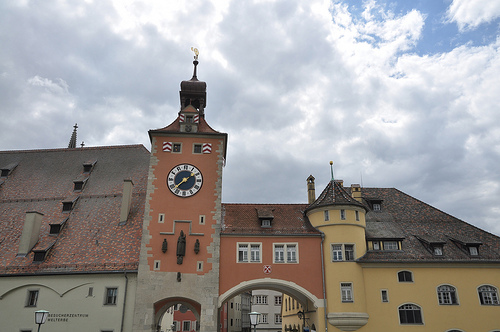Describe the architectural style of the buildings. The buildings in the image showcase a blend of traditional European architecture, featuring elements such as steeply pitched roofs, arched doorways, and windows with wooden shutters. What time period do these buildings appear to be from? The architectural features suggest that these buildings are likely from the late medieval to early Renaissance period, roughly between the 14th and 17th centuries. Imagine a festival happening in front of these buildings. Describe the scene. The festival brings the square to life with vibrant colors and cheerful music. People in traditional attire dance and celebrate, while street vendors sell local delicacies and handmade crafts. Strings of lights hang overhead, adding a festive glow as evening approaches. Children laugh and play, chasing each other around the square, while couples stroll, taking in the joyful atmosphere. If these buildings could talk, what stories might they tell? These buildings would share tales of golden ages and dark times. They'd recount the hustle and bustle of market days, the quiet solitude of snowy winters, and the laughter and tears of countless generations who've passed through. They'd speak of changes in architecture, technology, and society, and how their sturdy walls have weathered all with grace and dignity. Their stories would be filled with the everyday lives of people, from merchants and craftsmen to nobles and farmers. Can you write a short poem inspired by this image? Under the steeple’s timeless gaze,
In squares where history’s layers glaze,
Market folk and children play,
In shadows cast from ancient days.
Windows whisper tales of yore,
Of merchants, knights, and much folklore,
While clouds above drift endless by,
Bearing witness, on the sly. 